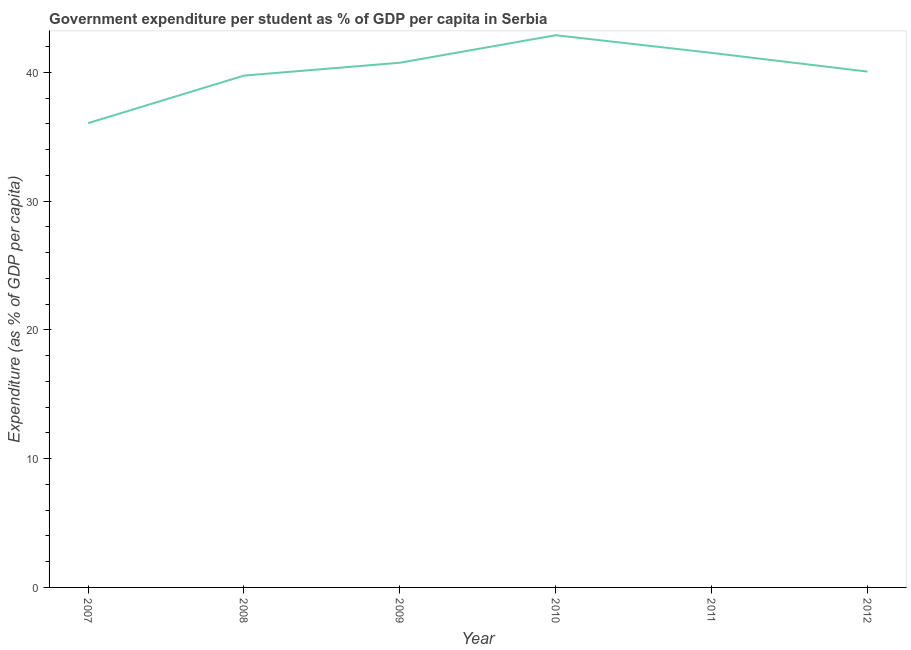What is the government expenditure per student in 2010?
Provide a short and direct response. 42.89. Across all years, what is the maximum government expenditure per student?
Provide a short and direct response. 42.89. Across all years, what is the minimum government expenditure per student?
Ensure brevity in your answer.  36.06. In which year was the government expenditure per student maximum?
Your response must be concise. 2010. What is the sum of the government expenditure per student?
Provide a succinct answer. 241.03. What is the difference between the government expenditure per student in 2008 and 2011?
Provide a succinct answer. -1.76. What is the average government expenditure per student per year?
Make the answer very short. 40.17. What is the median government expenditure per student?
Offer a terse response. 40.41. What is the ratio of the government expenditure per student in 2011 to that in 2012?
Provide a succinct answer. 1.04. What is the difference between the highest and the second highest government expenditure per student?
Provide a short and direct response. 1.37. What is the difference between the highest and the lowest government expenditure per student?
Ensure brevity in your answer.  6.83. In how many years, is the government expenditure per student greater than the average government expenditure per student taken over all years?
Make the answer very short. 3. Does the government expenditure per student monotonically increase over the years?
Your response must be concise. No. How many lines are there?
Ensure brevity in your answer.  1. What is the difference between two consecutive major ticks on the Y-axis?
Give a very brief answer. 10. Are the values on the major ticks of Y-axis written in scientific E-notation?
Your response must be concise. No. Does the graph contain any zero values?
Provide a short and direct response. No. What is the title of the graph?
Offer a very short reply. Government expenditure per student as % of GDP per capita in Serbia. What is the label or title of the X-axis?
Your answer should be very brief. Year. What is the label or title of the Y-axis?
Provide a short and direct response. Expenditure (as % of GDP per capita). What is the Expenditure (as % of GDP per capita) of 2007?
Give a very brief answer. 36.06. What is the Expenditure (as % of GDP per capita) in 2008?
Your answer should be compact. 39.75. What is the Expenditure (as % of GDP per capita) of 2009?
Your answer should be compact. 40.75. What is the Expenditure (as % of GDP per capita) in 2010?
Give a very brief answer. 42.89. What is the Expenditure (as % of GDP per capita) in 2011?
Your answer should be very brief. 41.52. What is the Expenditure (as % of GDP per capita) of 2012?
Offer a very short reply. 40.06. What is the difference between the Expenditure (as % of GDP per capita) in 2007 and 2008?
Make the answer very short. -3.69. What is the difference between the Expenditure (as % of GDP per capita) in 2007 and 2009?
Give a very brief answer. -4.69. What is the difference between the Expenditure (as % of GDP per capita) in 2007 and 2010?
Offer a very short reply. -6.83. What is the difference between the Expenditure (as % of GDP per capita) in 2007 and 2011?
Keep it short and to the point. -5.46. What is the difference between the Expenditure (as % of GDP per capita) in 2007 and 2012?
Make the answer very short. -4.01. What is the difference between the Expenditure (as % of GDP per capita) in 2008 and 2009?
Provide a short and direct response. -1. What is the difference between the Expenditure (as % of GDP per capita) in 2008 and 2010?
Provide a succinct answer. -3.14. What is the difference between the Expenditure (as % of GDP per capita) in 2008 and 2011?
Give a very brief answer. -1.76. What is the difference between the Expenditure (as % of GDP per capita) in 2008 and 2012?
Your answer should be compact. -0.31. What is the difference between the Expenditure (as % of GDP per capita) in 2009 and 2010?
Your answer should be compact. -2.14. What is the difference between the Expenditure (as % of GDP per capita) in 2009 and 2011?
Offer a terse response. -0.77. What is the difference between the Expenditure (as % of GDP per capita) in 2009 and 2012?
Your answer should be very brief. 0.69. What is the difference between the Expenditure (as % of GDP per capita) in 2010 and 2011?
Ensure brevity in your answer.  1.37. What is the difference between the Expenditure (as % of GDP per capita) in 2010 and 2012?
Your answer should be very brief. 2.82. What is the difference between the Expenditure (as % of GDP per capita) in 2011 and 2012?
Ensure brevity in your answer.  1.45. What is the ratio of the Expenditure (as % of GDP per capita) in 2007 to that in 2008?
Provide a succinct answer. 0.91. What is the ratio of the Expenditure (as % of GDP per capita) in 2007 to that in 2009?
Keep it short and to the point. 0.89. What is the ratio of the Expenditure (as % of GDP per capita) in 2007 to that in 2010?
Provide a succinct answer. 0.84. What is the ratio of the Expenditure (as % of GDP per capita) in 2007 to that in 2011?
Provide a short and direct response. 0.87. What is the ratio of the Expenditure (as % of GDP per capita) in 2007 to that in 2012?
Provide a succinct answer. 0.9. What is the ratio of the Expenditure (as % of GDP per capita) in 2008 to that in 2009?
Provide a succinct answer. 0.97. What is the ratio of the Expenditure (as % of GDP per capita) in 2008 to that in 2010?
Offer a very short reply. 0.93. What is the ratio of the Expenditure (as % of GDP per capita) in 2008 to that in 2011?
Provide a short and direct response. 0.96. What is the ratio of the Expenditure (as % of GDP per capita) in 2009 to that in 2010?
Ensure brevity in your answer.  0.95. What is the ratio of the Expenditure (as % of GDP per capita) in 2009 to that in 2012?
Offer a terse response. 1.02. What is the ratio of the Expenditure (as % of GDP per capita) in 2010 to that in 2011?
Make the answer very short. 1.03. What is the ratio of the Expenditure (as % of GDP per capita) in 2010 to that in 2012?
Provide a succinct answer. 1.07. What is the ratio of the Expenditure (as % of GDP per capita) in 2011 to that in 2012?
Ensure brevity in your answer.  1.04. 